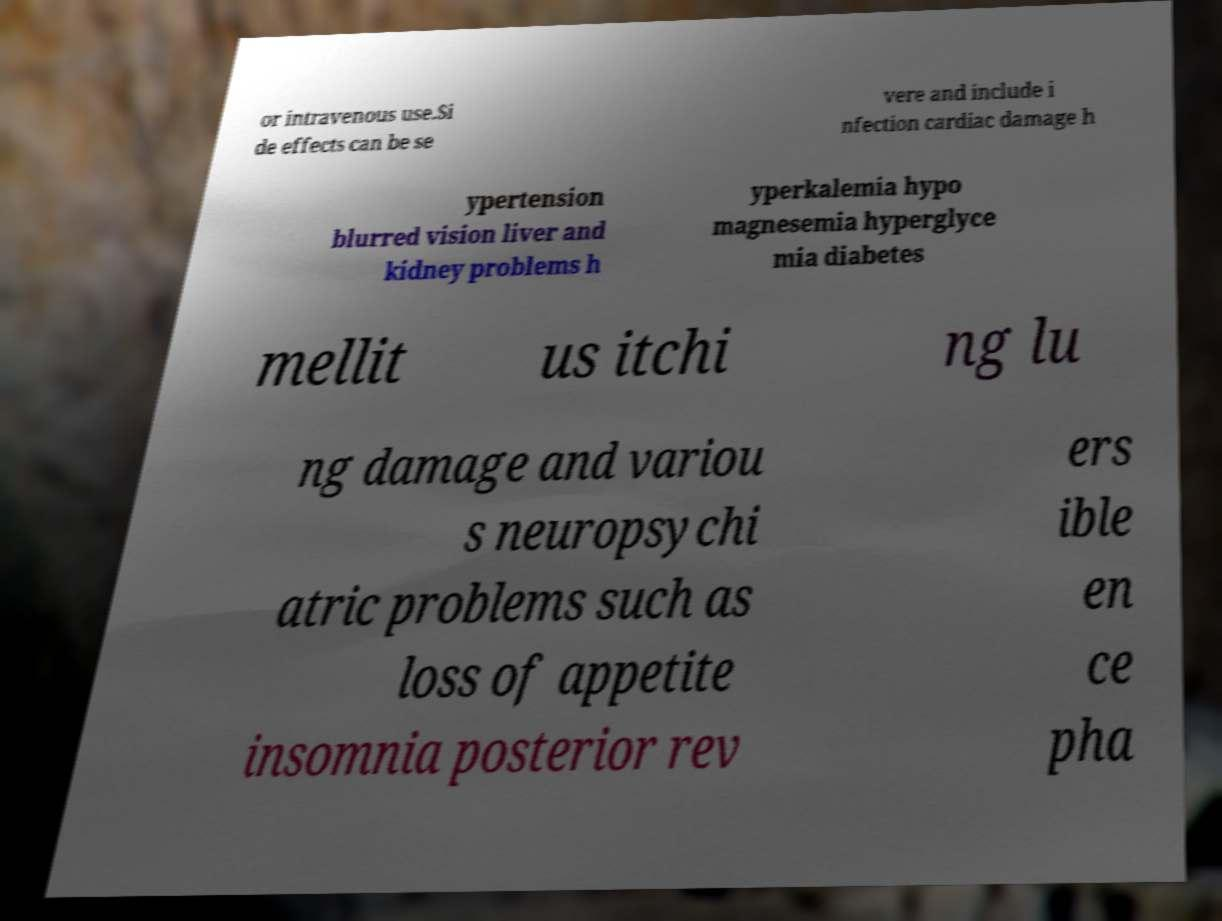There's text embedded in this image that I need extracted. Can you transcribe it verbatim? or intravenous use.Si de effects can be se vere and include i nfection cardiac damage h ypertension blurred vision liver and kidney problems h yperkalemia hypo magnesemia hyperglyce mia diabetes mellit us itchi ng lu ng damage and variou s neuropsychi atric problems such as loss of appetite insomnia posterior rev ers ible en ce pha 